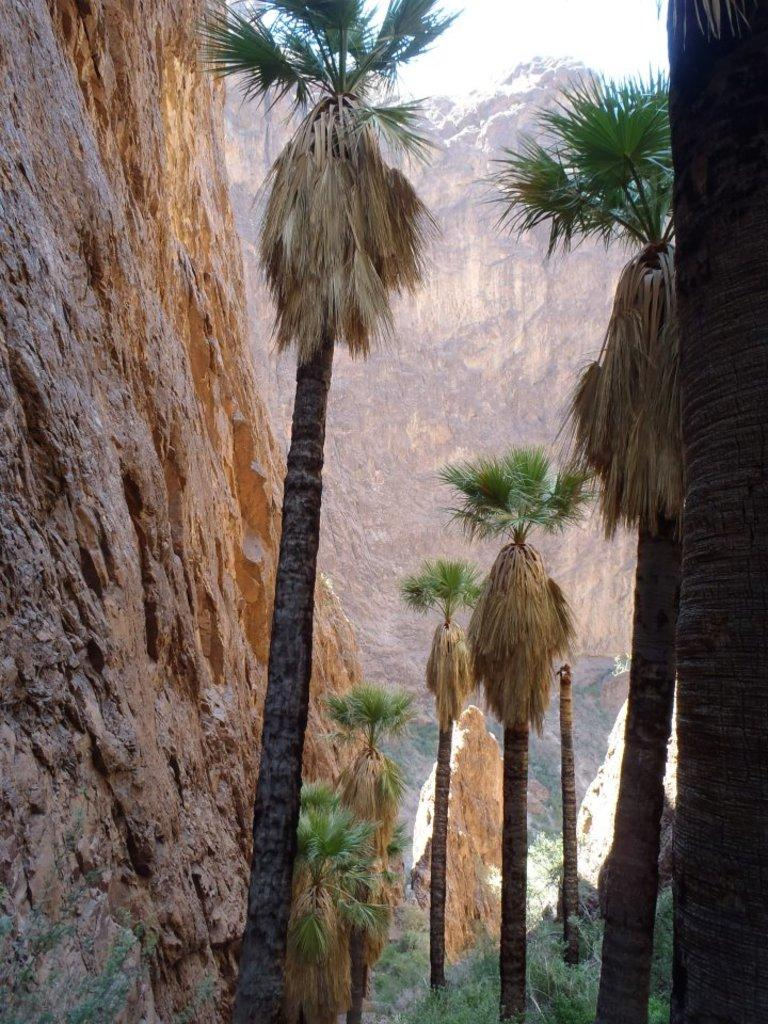What type of vegetation can be seen in the image? There are trees in the image. What type of geological feature is present in the image? There are brown color mountains in the image. What type of ground cover is visible in the image? There is green color grass in the image. What type of collar can be seen on the wax figure in the image? There is no wax figure or collar present in the image. What type of medical advice can be obtained from the doctor in the image? There is no doctor present in the image. 